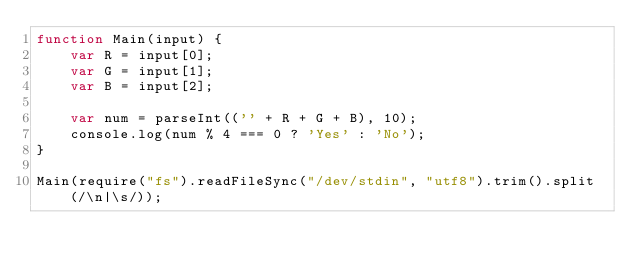Convert code to text. <code><loc_0><loc_0><loc_500><loc_500><_JavaScript_>function Main(input) {
    var R = input[0];
    var G = input[1];
    var B = input[2];

    var num = parseInt(('' + R + G + B), 10);
    console.log(num % 4 === 0 ? 'Yes' : 'No');
}
 
Main(require("fs").readFileSync("/dev/stdin", "utf8").trim().split(/\n|\s/));</code> 